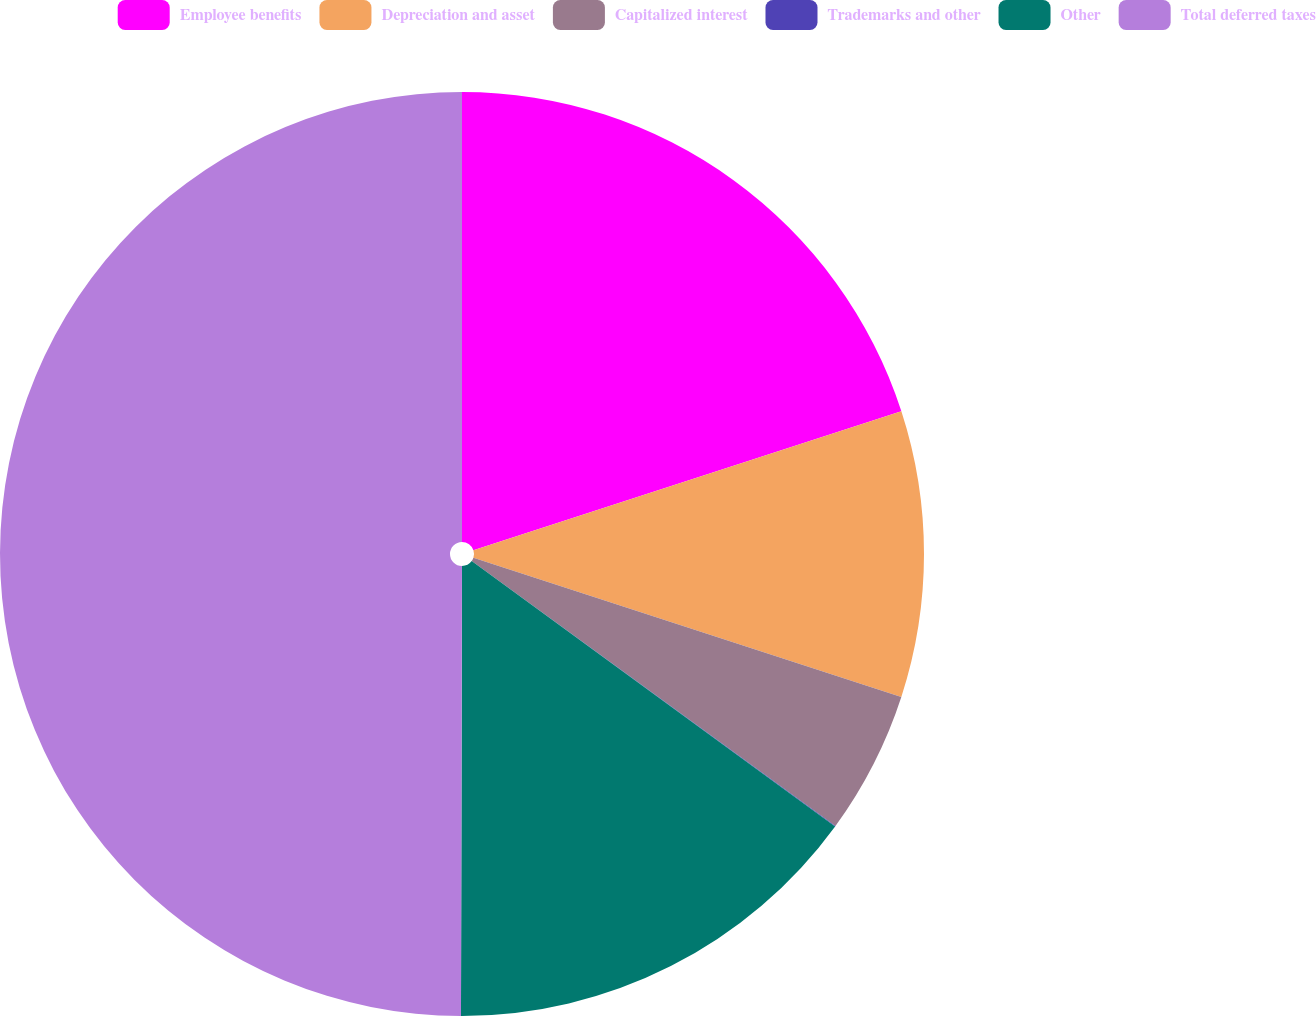Convert chart. <chart><loc_0><loc_0><loc_500><loc_500><pie_chart><fcel>Employee benefits<fcel>Depreciation and asset<fcel>Capitalized interest<fcel>Trademarks and other<fcel>Other<fcel>Total deferred taxes<nl><fcel>20.0%<fcel>10.01%<fcel>5.01%<fcel>0.02%<fcel>15.0%<fcel>49.97%<nl></chart> 